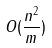<formula> <loc_0><loc_0><loc_500><loc_500>O ( \frac { n ^ { 2 } } { m } )</formula> 